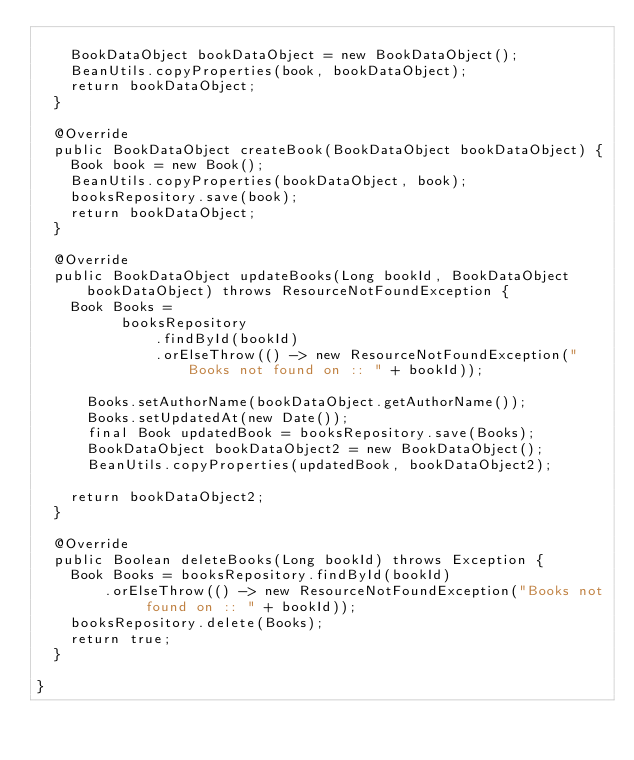<code> <loc_0><loc_0><loc_500><loc_500><_Java_>		
		BookDataObject bookDataObject = new BookDataObject();
		BeanUtils.copyProperties(book, bookDataObject);
		return bookDataObject;
	}

	@Override
	public BookDataObject createBook(BookDataObject bookDataObject) {
		Book book = new Book();
		BeanUtils.copyProperties(bookDataObject, book);
		booksRepository.save(book);
		return bookDataObject;
	}

	@Override
	public BookDataObject updateBooks(Long bookId, BookDataObject bookDataObject) throws ResourceNotFoundException {
		Book Books =
	    		booksRepository
	            .findById(bookId)
	            .orElseThrow(() -> new ResourceNotFoundException("Books not found on :: " + bookId));

	    Books.setAuthorName(bookDataObject.getAuthorName());
	    Books.setUpdatedAt(new Date());
	    final Book updatedBook = booksRepository.save(Books);
	    BookDataObject bookDataObject2 = new BookDataObject();
	    BeanUtils.copyProperties(updatedBook, bookDataObject2);
	    
		return bookDataObject2;
	}

	@Override
	public Boolean deleteBooks(Long bookId) throws Exception {
		Book Books = booksRepository.findById(bookId)
				.orElseThrow(() -> new ResourceNotFoundException("Books not found on :: " + bookId));
		booksRepository.delete(Books);
		return true;
	}
	
}
</code> 